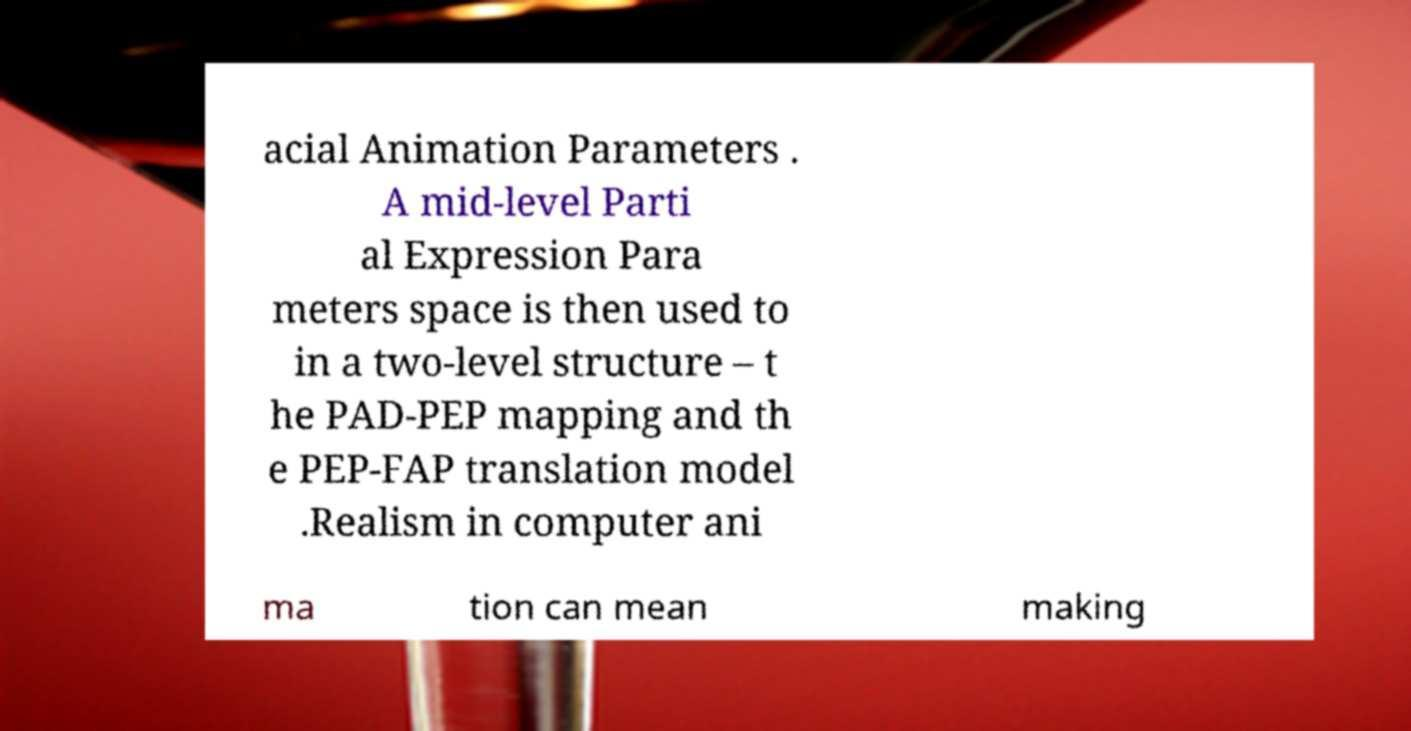What messages or text are displayed in this image? I need them in a readable, typed format. acial Animation Parameters . A mid-level Parti al Expression Para meters space is then used to in a two-level structure – t he PAD-PEP mapping and th e PEP-FAP translation model .Realism in computer ani ma tion can mean making 